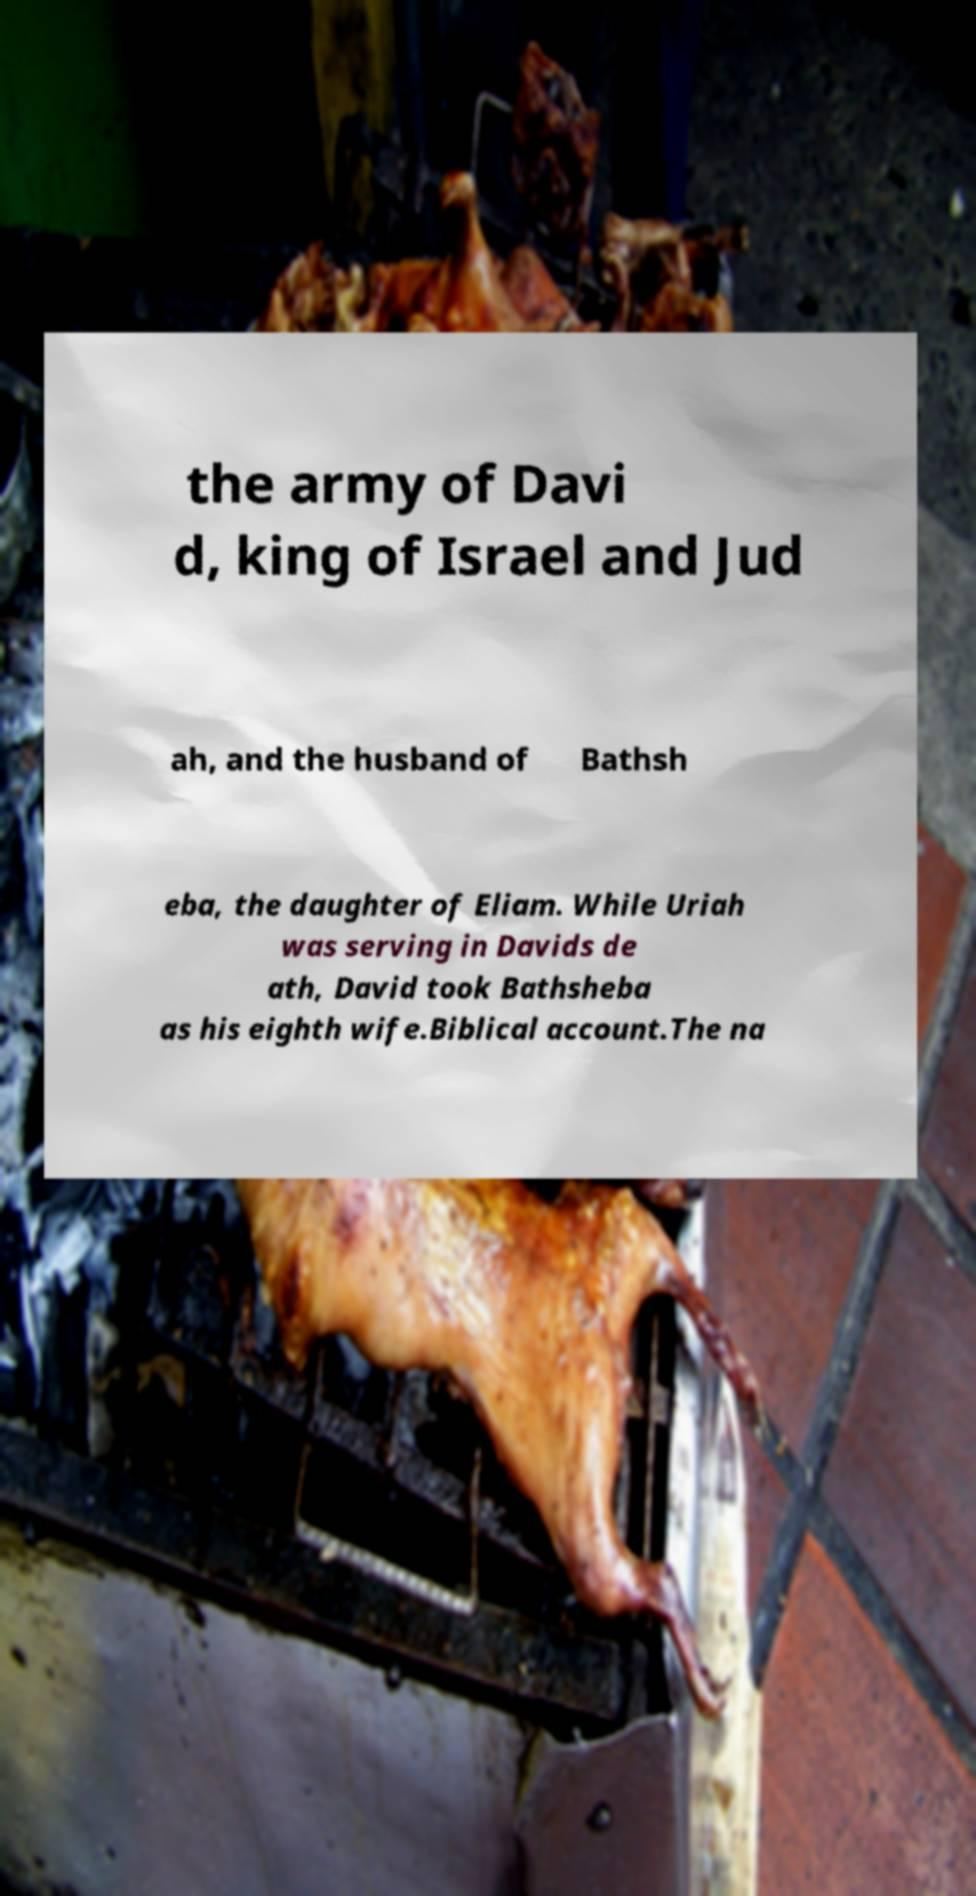Can you accurately transcribe the text from the provided image for me? the army of Davi d, king of Israel and Jud ah, and the husband of Bathsh eba, the daughter of Eliam. While Uriah was serving in Davids de ath, David took Bathsheba as his eighth wife.Biblical account.The na 